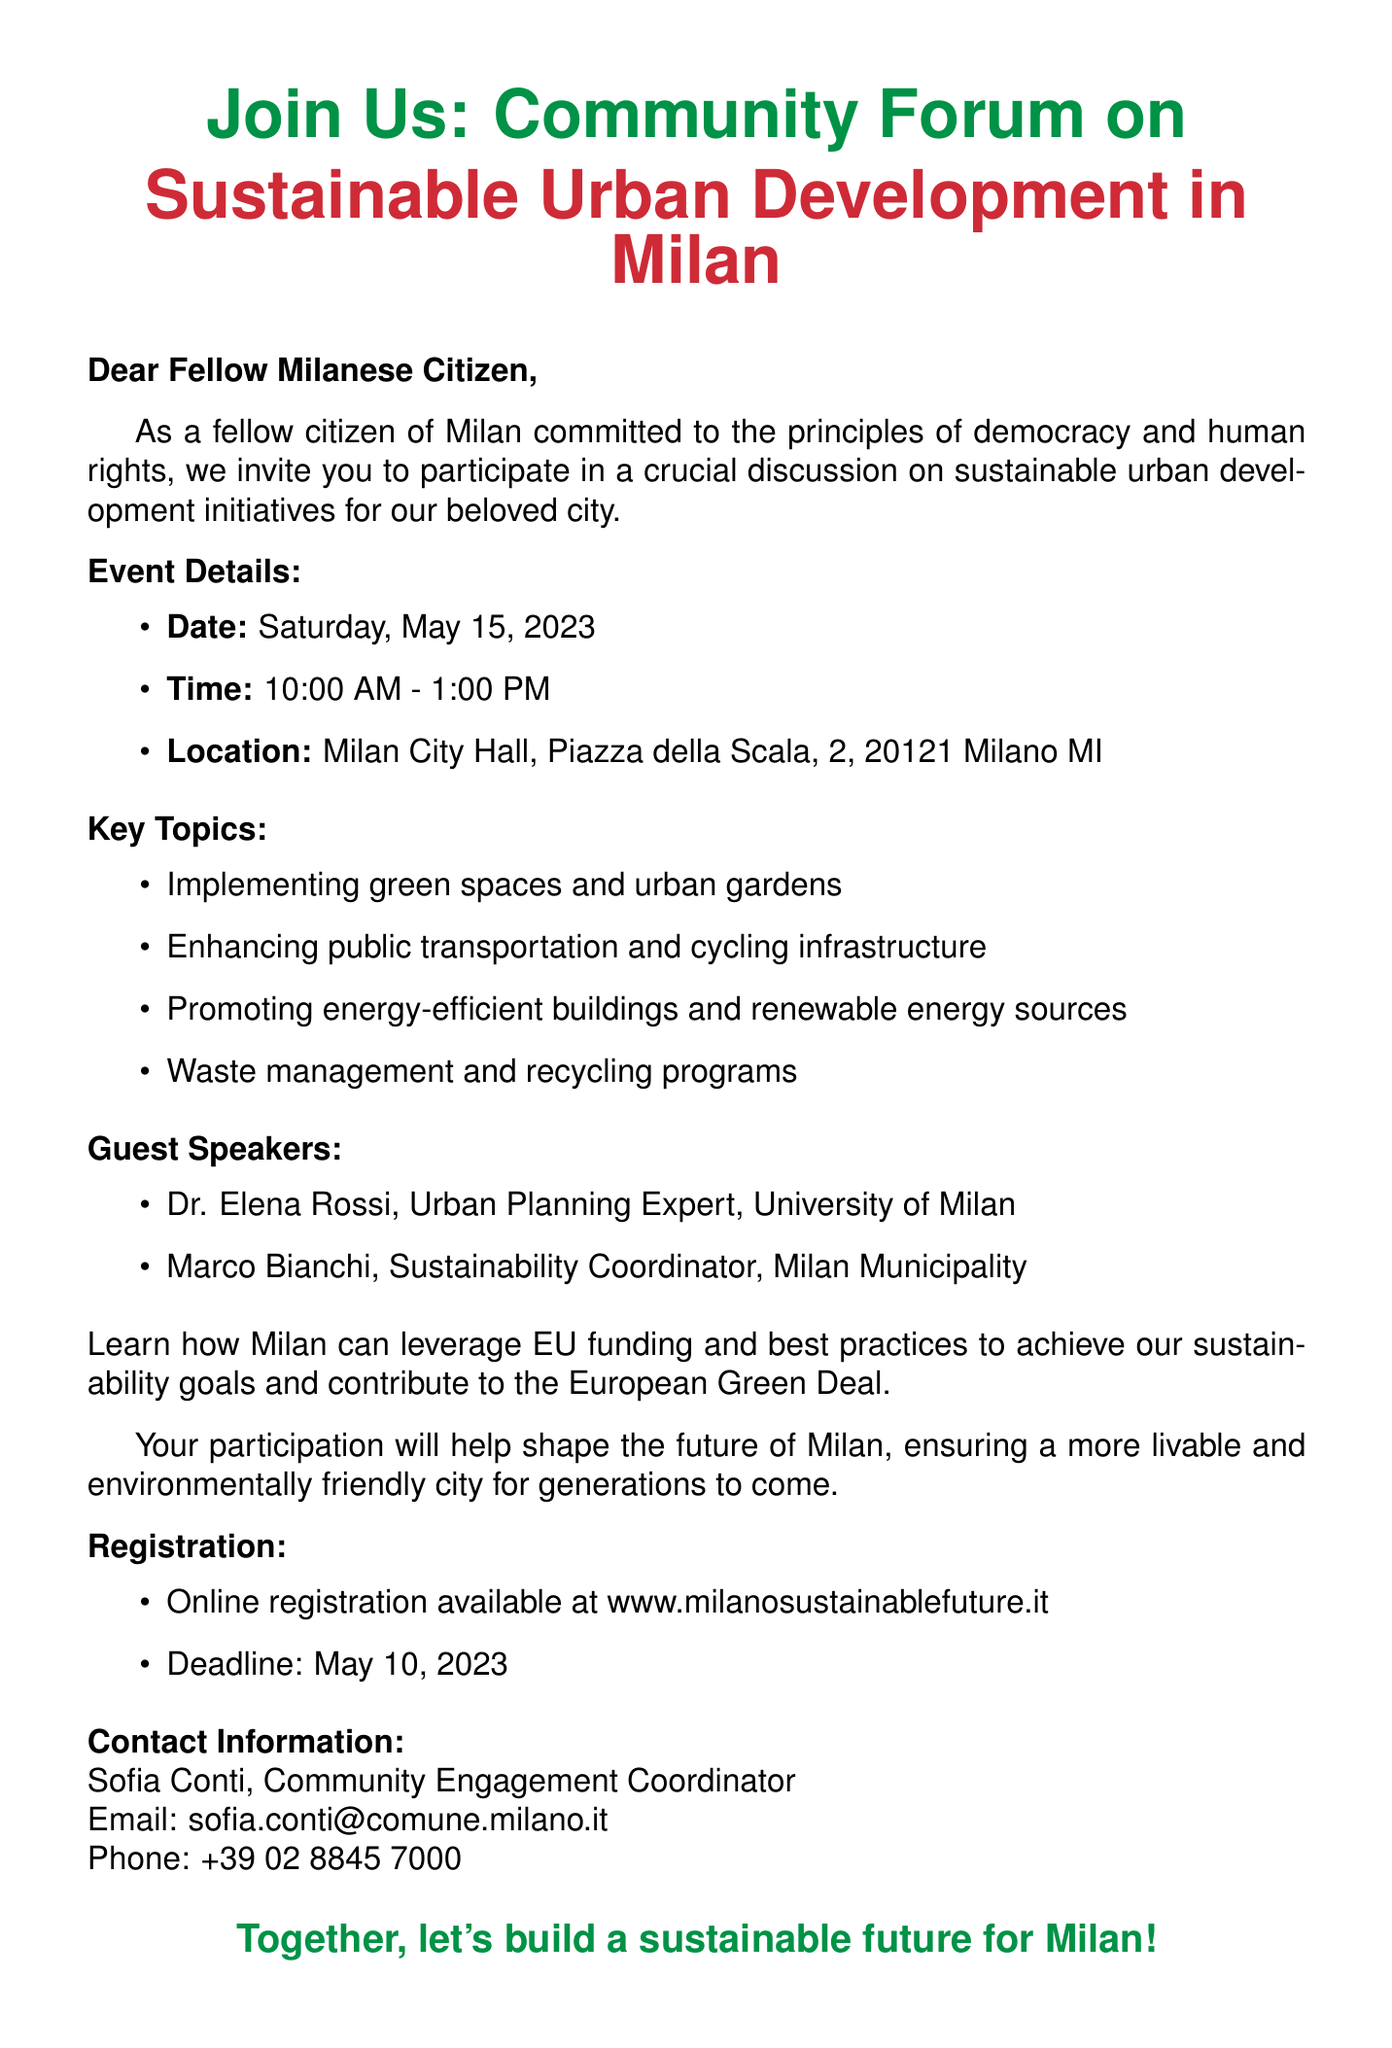What is the date of the forum? The date of the forum is explicitly stated in the event details section of the document.
Answer: Saturday, May 15, 2023 What is the location of the event? The location is provided in the event details section under the location bullet point.
Answer: Milan City Hall, Piazza della Scala, 2, 20121 Milano MI Who is one of the guest speakers? The document lists guest speakers in a specific section where their names and titles are presented.
Answer: Dr. Elena Rossi What is the registration deadline? The registration deadline is mentioned in the registration section of the document.
Answer: May 10, 2023 What is one of the key topics discussed at the forum? The document outlines several key topics that will be discussed at the forum.
Answer: Implementing green spaces and urban gardens How can Milan benefit from EU initiatives? The document explains a connection to EU funding and practices that could aid Milan's sustainability goals.
Answer: EU funding and best practices Who is the contact person for the event? The contact information section provides details about the contact person for the event.
Answer: Sofia Conti What time does the forum start? The time is clearly outlined in the event details section of the document.
Answer: 10:00 AM 